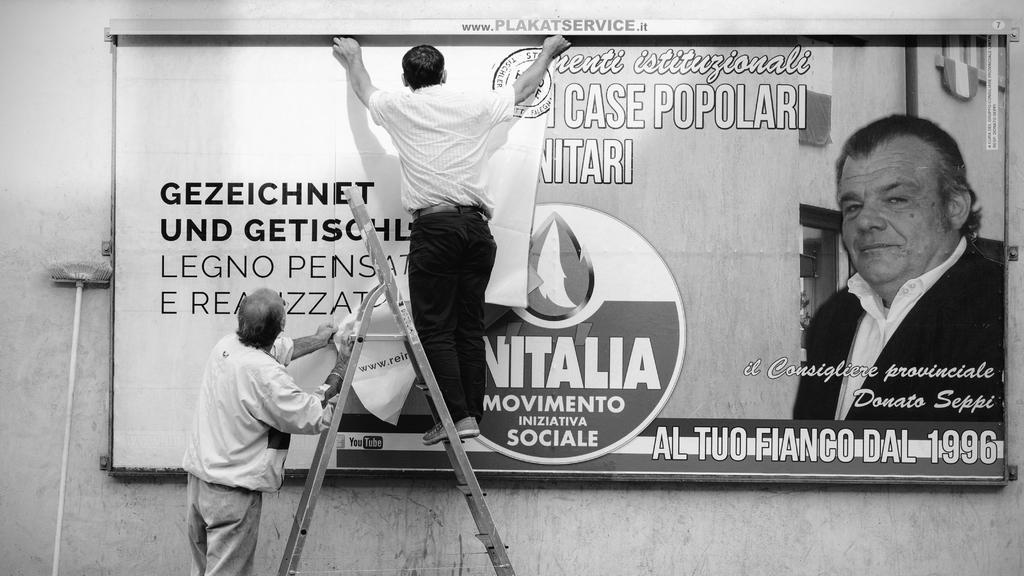In one or two sentences, can you explain what this image depicts? It is a black and white image. In this image, we can see two persons. Here a person is holding a banner and stand. Another person is standing on the stand and holding banner. Background there is a wall. On the wall, there is a wall and broomstick. On the board and banner, we can see some text. Here there is a person on the board. 